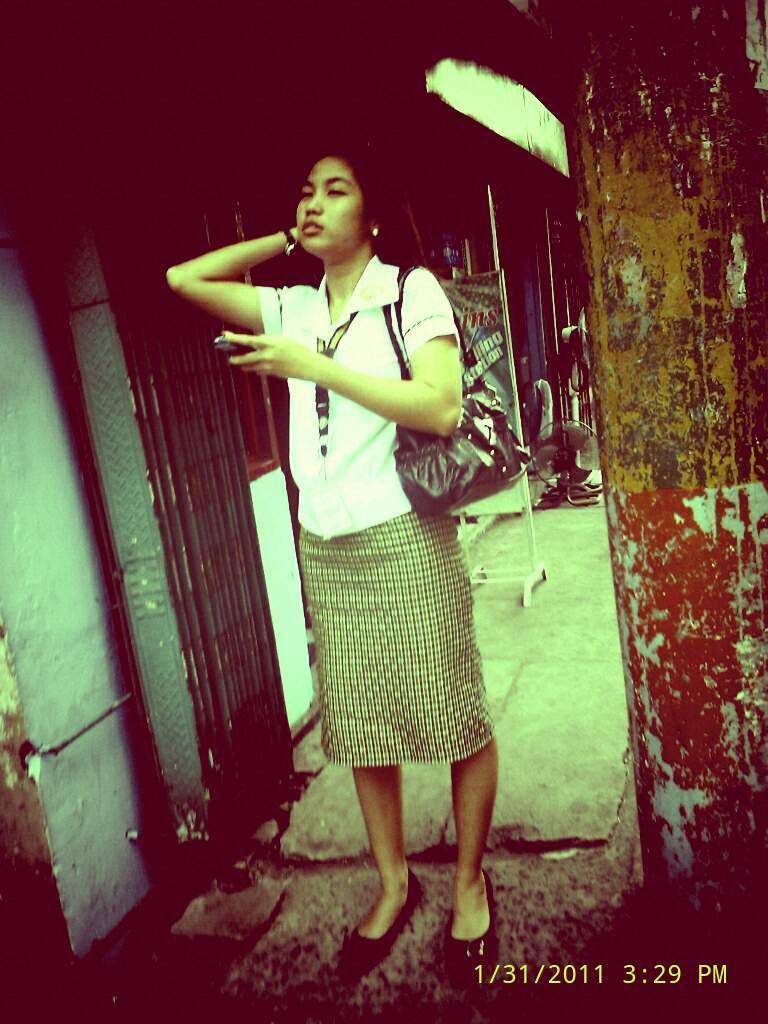Could you give a brief overview of what you see in this image? This is an edited image. There is a person in the middle. She is a woman. She has a bag. She is wearing a white dress. 